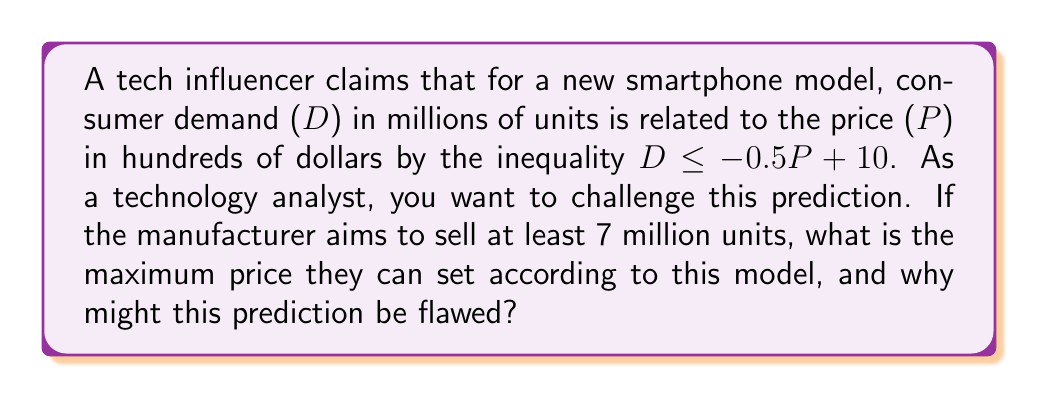Give your solution to this math problem. 1) Let's start with the given inequality:
   $D \leq -0.5P + 10$

2) We want to find the maximum price P when D is at least 7 million units. So, we can replace the inequality with an equation:
   $7 = -0.5P + 10$

3) Solve for P:
   $7 = -0.5P + 10$
   $-3 = -0.5P$
   $P = 6$

4) Therefore, the maximum price is $600 (since P is in hundreds of dollars).

5) To challenge this prediction:
   a) The model assumes a linear relationship, which may not hold in reality.
   b) It doesn't account for factors like brand loyalty, features, or competition.
   c) The coefficients (-0.5 and 10) might not be accurate or could change over time.
   d) The model doesn't consider price elasticity variations at different price points.
   e) It ignores potential supply constraints or production costs.

6) These limitations suggest that the actual maximum price could be higher or lower, depending on various market factors not captured by this simple linear model.
Answer: $600; model oversimplifies complex market dynamics 